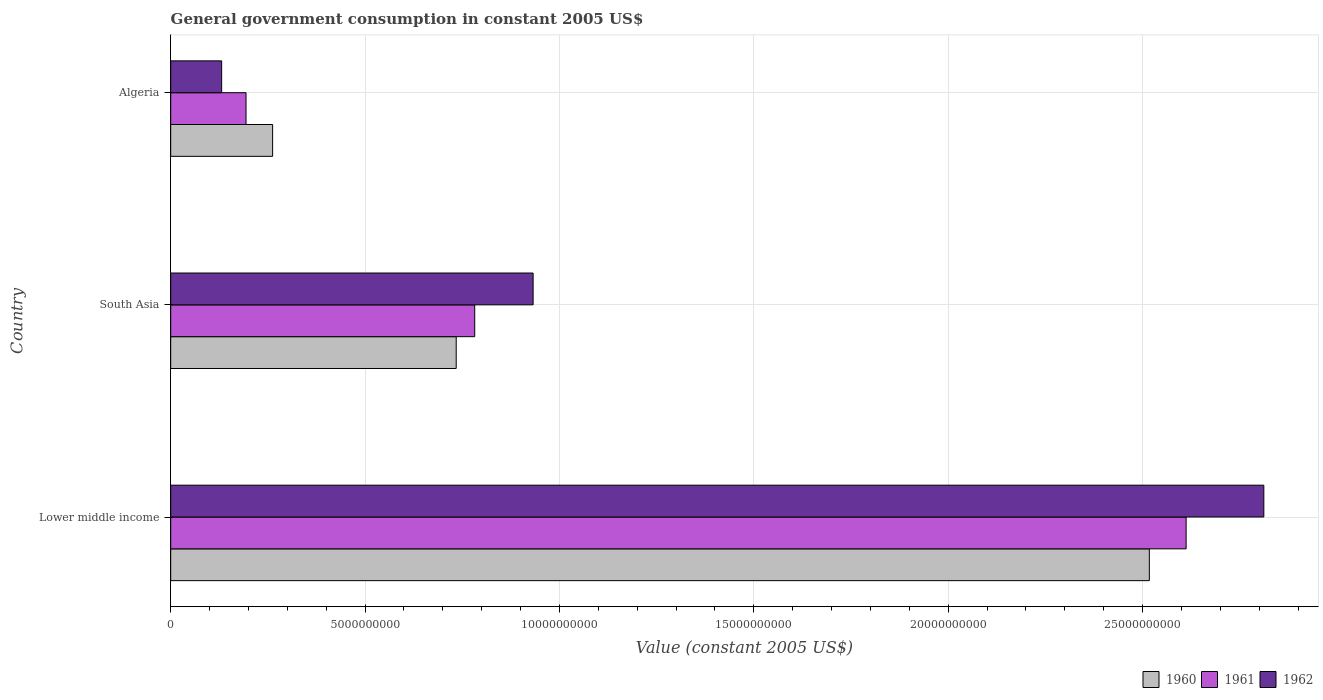How many different coloured bars are there?
Your answer should be compact. 3. Are the number of bars per tick equal to the number of legend labels?
Offer a very short reply. Yes. How many bars are there on the 2nd tick from the top?
Give a very brief answer. 3. How many bars are there on the 2nd tick from the bottom?
Provide a short and direct response. 3. What is the label of the 3rd group of bars from the top?
Offer a very short reply. Lower middle income. What is the government conusmption in 1960 in Algeria?
Keep it short and to the point. 2.62e+09. Across all countries, what is the maximum government conusmption in 1962?
Offer a terse response. 2.81e+1. Across all countries, what is the minimum government conusmption in 1960?
Give a very brief answer. 2.62e+09. In which country was the government conusmption in 1960 maximum?
Ensure brevity in your answer.  Lower middle income. In which country was the government conusmption in 1960 minimum?
Give a very brief answer. Algeria. What is the total government conusmption in 1961 in the graph?
Offer a very short reply. 3.59e+1. What is the difference between the government conusmption in 1960 in Algeria and that in South Asia?
Keep it short and to the point. -4.72e+09. What is the difference between the government conusmption in 1960 in Algeria and the government conusmption in 1961 in Lower middle income?
Your answer should be very brief. -2.35e+1. What is the average government conusmption in 1962 per country?
Your response must be concise. 1.29e+1. What is the difference between the government conusmption in 1960 and government conusmption in 1961 in South Asia?
Provide a short and direct response. -4.76e+08. What is the ratio of the government conusmption in 1961 in Algeria to that in South Asia?
Offer a terse response. 0.25. Is the difference between the government conusmption in 1960 in Algeria and Lower middle income greater than the difference between the government conusmption in 1961 in Algeria and Lower middle income?
Give a very brief answer. Yes. What is the difference between the highest and the second highest government conusmption in 1962?
Your answer should be compact. 1.88e+1. What is the difference between the highest and the lowest government conusmption in 1960?
Keep it short and to the point. 2.26e+1. In how many countries, is the government conusmption in 1962 greater than the average government conusmption in 1962 taken over all countries?
Provide a short and direct response. 1. What does the 1st bar from the bottom in South Asia represents?
Offer a terse response. 1960. How many bars are there?
Give a very brief answer. 9. What is the difference between two consecutive major ticks on the X-axis?
Give a very brief answer. 5.00e+09. Are the values on the major ticks of X-axis written in scientific E-notation?
Give a very brief answer. No. Does the graph contain grids?
Offer a very short reply. Yes. Where does the legend appear in the graph?
Provide a succinct answer. Bottom right. How are the legend labels stacked?
Give a very brief answer. Horizontal. What is the title of the graph?
Provide a succinct answer. General government consumption in constant 2005 US$. What is the label or title of the X-axis?
Make the answer very short. Value (constant 2005 US$). What is the Value (constant 2005 US$) in 1960 in Lower middle income?
Provide a short and direct response. 2.52e+1. What is the Value (constant 2005 US$) in 1961 in Lower middle income?
Keep it short and to the point. 2.61e+1. What is the Value (constant 2005 US$) of 1962 in Lower middle income?
Provide a succinct answer. 2.81e+1. What is the Value (constant 2005 US$) in 1960 in South Asia?
Provide a succinct answer. 7.34e+09. What is the Value (constant 2005 US$) in 1961 in South Asia?
Make the answer very short. 7.82e+09. What is the Value (constant 2005 US$) in 1962 in South Asia?
Your response must be concise. 9.32e+09. What is the Value (constant 2005 US$) in 1960 in Algeria?
Offer a very short reply. 2.62e+09. What is the Value (constant 2005 US$) in 1961 in Algeria?
Keep it short and to the point. 1.94e+09. What is the Value (constant 2005 US$) of 1962 in Algeria?
Provide a succinct answer. 1.31e+09. Across all countries, what is the maximum Value (constant 2005 US$) in 1960?
Provide a succinct answer. 2.52e+1. Across all countries, what is the maximum Value (constant 2005 US$) in 1961?
Keep it short and to the point. 2.61e+1. Across all countries, what is the maximum Value (constant 2005 US$) of 1962?
Make the answer very short. 2.81e+1. Across all countries, what is the minimum Value (constant 2005 US$) in 1960?
Offer a terse response. 2.62e+09. Across all countries, what is the minimum Value (constant 2005 US$) of 1961?
Your response must be concise. 1.94e+09. Across all countries, what is the minimum Value (constant 2005 US$) of 1962?
Keep it short and to the point. 1.31e+09. What is the total Value (constant 2005 US$) in 1960 in the graph?
Give a very brief answer. 3.51e+1. What is the total Value (constant 2005 US$) in 1961 in the graph?
Your answer should be very brief. 3.59e+1. What is the total Value (constant 2005 US$) in 1962 in the graph?
Your answer should be compact. 3.88e+1. What is the difference between the Value (constant 2005 US$) of 1960 in Lower middle income and that in South Asia?
Provide a short and direct response. 1.78e+1. What is the difference between the Value (constant 2005 US$) of 1961 in Lower middle income and that in South Asia?
Make the answer very short. 1.83e+1. What is the difference between the Value (constant 2005 US$) of 1962 in Lower middle income and that in South Asia?
Make the answer very short. 1.88e+1. What is the difference between the Value (constant 2005 US$) in 1960 in Lower middle income and that in Algeria?
Make the answer very short. 2.26e+1. What is the difference between the Value (constant 2005 US$) of 1961 in Lower middle income and that in Algeria?
Make the answer very short. 2.42e+1. What is the difference between the Value (constant 2005 US$) in 1962 in Lower middle income and that in Algeria?
Provide a succinct answer. 2.68e+1. What is the difference between the Value (constant 2005 US$) in 1960 in South Asia and that in Algeria?
Keep it short and to the point. 4.72e+09. What is the difference between the Value (constant 2005 US$) of 1961 in South Asia and that in Algeria?
Your answer should be very brief. 5.88e+09. What is the difference between the Value (constant 2005 US$) of 1962 in South Asia and that in Algeria?
Your answer should be very brief. 8.01e+09. What is the difference between the Value (constant 2005 US$) in 1960 in Lower middle income and the Value (constant 2005 US$) in 1961 in South Asia?
Your answer should be very brief. 1.74e+1. What is the difference between the Value (constant 2005 US$) of 1960 in Lower middle income and the Value (constant 2005 US$) of 1962 in South Asia?
Make the answer very short. 1.59e+1. What is the difference between the Value (constant 2005 US$) in 1961 in Lower middle income and the Value (constant 2005 US$) in 1962 in South Asia?
Your answer should be very brief. 1.68e+1. What is the difference between the Value (constant 2005 US$) of 1960 in Lower middle income and the Value (constant 2005 US$) of 1961 in Algeria?
Ensure brevity in your answer.  2.32e+1. What is the difference between the Value (constant 2005 US$) in 1960 in Lower middle income and the Value (constant 2005 US$) in 1962 in Algeria?
Keep it short and to the point. 2.39e+1. What is the difference between the Value (constant 2005 US$) in 1961 in Lower middle income and the Value (constant 2005 US$) in 1962 in Algeria?
Offer a very short reply. 2.48e+1. What is the difference between the Value (constant 2005 US$) in 1960 in South Asia and the Value (constant 2005 US$) in 1961 in Algeria?
Your response must be concise. 5.41e+09. What is the difference between the Value (constant 2005 US$) in 1960 in South Asia and the Value (constant 2005 US$) in 1962 in Algeria?
Offer a very short reply. 6.03e+09. What is the difference between the Value (constant 2005 US$) of 1961 in South Asia and the Value (constant 2005 US$) of 1962 in Algeria?
Keep it short and to the point. 6.51e+09. What is the average Value (constant 2005 US$) in 1960 per country?
Provide a short and direct response. 1.17e+1. What is the average Value (constant 2005 US$) of 1961 per country?
Your answer should be very brief. 1.20e+1. What is the average Value (constant 2005 US$) in 1962 per country?
Offer a terse response. 1.29e+1. What is the difference between the Value (constant 2005 US$) in 1960 and Value (constant 2005 US$) in 1961 in Lower middle income?
Give a very brief answer. -9.46e+08. What is the difference between the Value (constant 2005 US$) of 1960 and Value (constant 2005 US$) of 1962 in Lower middle income?
Your response must be concise. -2.95e+09. What is the difference between the Value (constant 2005 US$) of 1961 and Value (constant 2005 US$) of 1962 in Lower middle income?
Give a very brief answer. -2.00e+09. What is the difference between the Value (constant 2005 US$) of 1960 and Value (constant 2005 US$) of 1961 in South Asia?
Provide a short and direct response. -4.76e+08. What is the difference between the Value (constant 2005 US$) in 1960 and Value (constant 2005 US$) in 1962 in South Asia?
Ensure brevity in your answer.  -1.98e+09. What is the difference between the Value (constant 2005 US$) of 1961 and Value (constant 2005 US$) of 1962 in South Asia?
Ensure brevity in your answer.  -1.50e+09. What is the difference between the Value (constant 2005 US$) of 1960 and Value (constant 2005 US$) of 1961 in Algeria?
Provide a succinct answer. 6.84e+08. What is the difference between the Value (constant 2005 US$) of 1960 and Value (constant 2005 US$) of 1962 in Algeria?
Ensure brevity in your answer.  1.31e+09. What is the difference between the Value (constant 2005 US$) in 1961 and Value (constant 2005 US$) in 1962 in Algeria?
Your answer should be very brief. 6.27e+08. What is the ratio of the Value (constant 2005 US$) of 1960 in Lower middle income to that in South Asia?
Your answer should be compact. 3.43. What is the ratio of the Value (constant 2005 US$) of 1961 in Lower middle income to that in South Asia?
Offer a terse response. 3.34. What is the ratio of the Value (constant 2005 US$) of 1962 in Lower middle income to that in South Asia?
Provide a short and direct response. 3.02. What is the ratio of the Value (constant 2005 US$) in 1960 in Lower middle income to that in Algeria?
Provide a short and direct response. 9.6. What is the ratio of the Value (constant 2005 US$) of 1961 in Lower middle income to that in Algeria?
Your response must be concise. 13.48. What is the ratio of the Value (constant 2005 US$) in 1962 in Lower middle income to that in Algeria?
Offer a terse response. 21.45. What is the ratio of the Value (constant 2005 US$) in 1960 in South Asia to that in Algeria?
Your answer should be very brief. 2.8. What is the ratio of the Value (constant 2005 US$) in 1961 in South Asia to that in Algeria?
Ensure brevity in your answer.  4.04. What is the ratio of the Value (constant 2005 US$) in 1962 in South Asia to that in Algeria?
Your response must be concise. 7.11. What is the difference between the highest and the second highest Value (constant 2005 US$) in 1960?
Your answer should be very brief. 1.78e+1. What is the difference between the highest and the second highest Value (constant 2005 US$) of 1961?
Offer a terse response. 1.83e+1. What is the difference between the highest and the second highest Value (constant 2005 US$) in 1962?
Give a very brief answer. 1.88e+1. What is the difference between the highest and the lowest Value (constant 2005 US$) in 1960?
Your response must be concise. 2.26e+1. What is the difference between the highest and the lowest Value (constant 2005 US$) of 1961?
Give a very brief answer. 2.42e+1. What is the difference between the highest and the lowest Value (constant 2005 US$) in 1962?
Provide a succinct answer. 2.68e+1. 